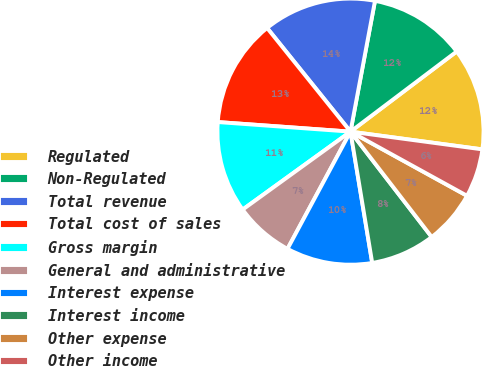Convert chart to OTSL. <chart><loc_0><loc_0><loc_500><loc_500><pie_chart><fcel>Regulated<fcel>Non-Regulated<fcel>Total revenue<fcel>Total cost of sales<fcel>Gross margin<fcel>General and administrative<fcel>Interest expense<fcel>Interest income<fcel>Other expense<fcel>Other income<nl><fcel>12.42%<fcel>11.76%<fcel>13.73%<fcel>13.07%<fcel>11.11%<fcel>7.19%<fcel>10.46%<fcel>7.84%<fcel>6.54%<fcel>5.88%<nl></chart> 